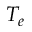<formula> <loc_0><loc_0><loc_500><loc_500>T _ { e }</formula> 